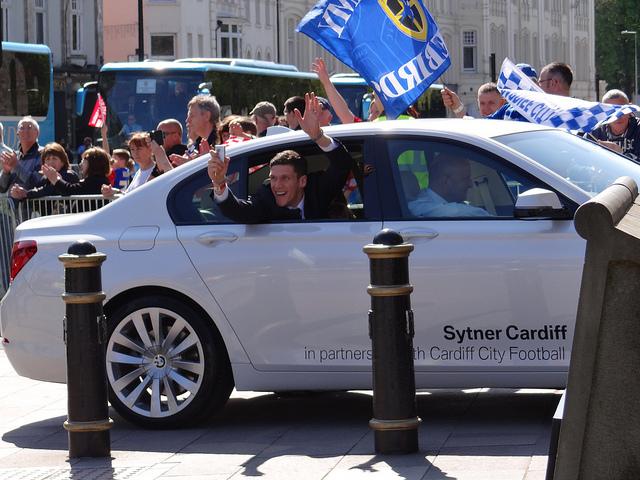What is the name of the car?
Concise answer only. Sytner cardiff. Is the man's hands inside of the car?
Write a very short answer. No. What color is the car?
Write a very short answer. White. 